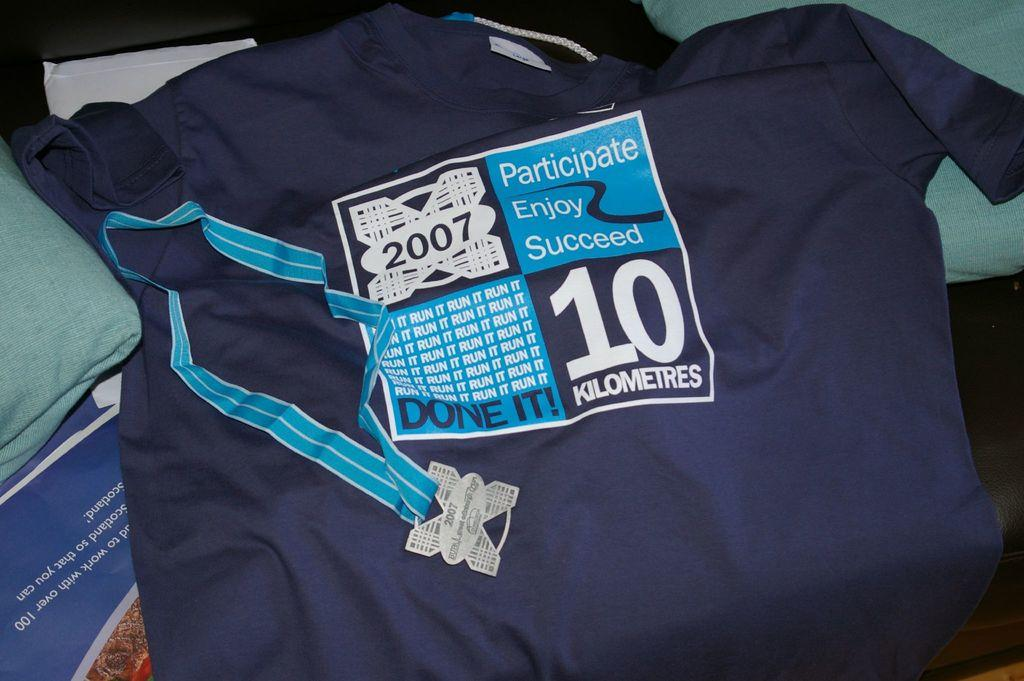<image>
Write a terse but informative summary of the picture. A blue t-short for the 2007 10K run is displayed with a participation medal. 